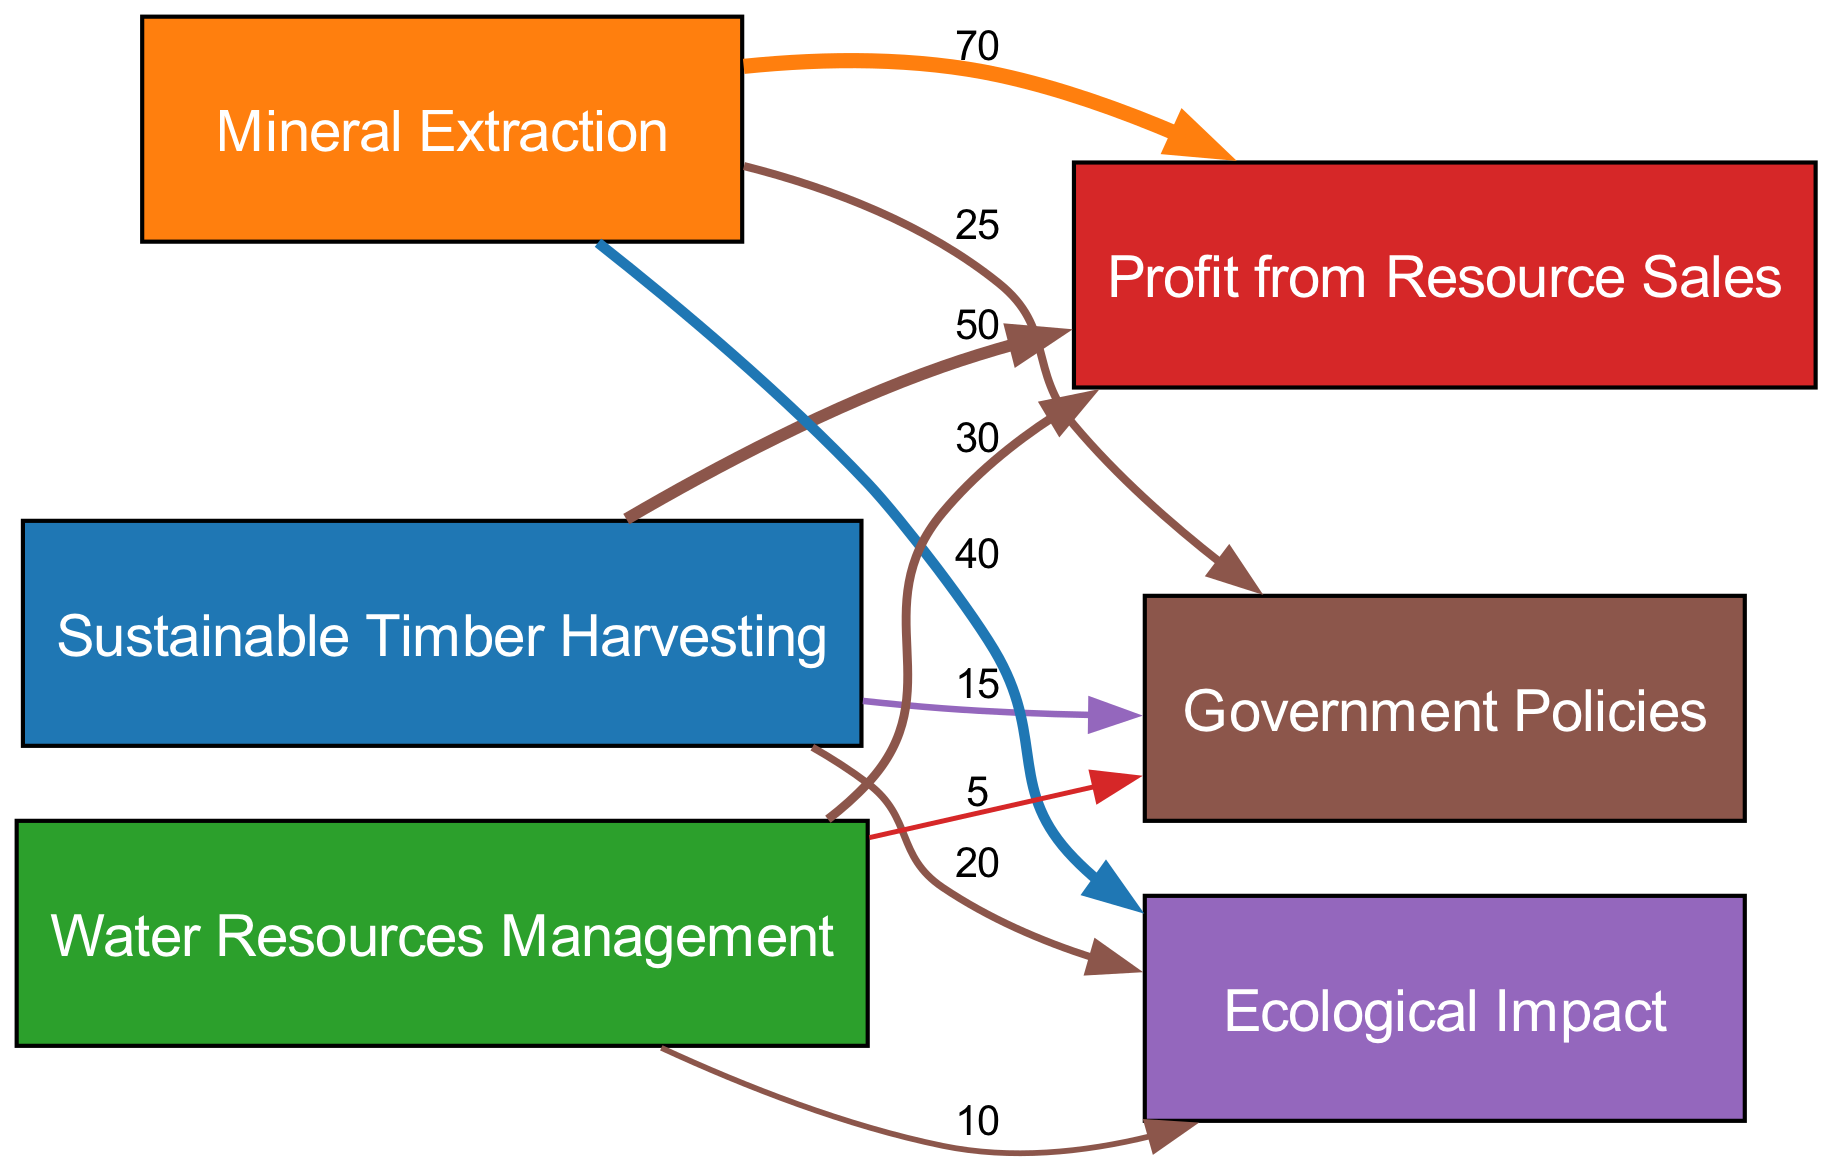What is the total economic gain from mining? The link from Mining to Economic Gain shows a value of 70, which directly represents the economic gain attributed to mining activities.
Answer: 70 What percentage of the economic gain comes from forestry? The economic gain from Forestry is 50. The total economic gain is 70 (mining) + 50 (forestry) + 30 (water rights) = 150. The percentage from forestry is (50/150) * 100 = 33.33%.
Answer: 33.33% How many nodes are there in the diagram? There are a total of six nodes: Forestry, Mining, Water Rights, Economic Gain, Environment, and Regulations.
Answer: 6 What is the total environmental impact from resource extraction? The environmental impacts are: 20 (forestry) + 40 (mining) + 10 (water rights) = 70. This sum represents the total negative impact on the environment due to resource extraction.
Answer: 70 Which resource has the highest environmental impact? Mining has the highest environmental impact with a value of 40 as shown by the link from Mining to the Environment.
Answer: Mining What is the total value flowing into regulations from all resources? The values flowing into Regulations are: 25 (mining) + 15 (forestry) + 5 (water rights) = 45. This represents the total influence of different resources on regulatory measures.
Answer: 45 What is the flow of environmental impact from water rights? The flow from Water Rights to Environment is valued at 10, indicating the ecological impact resulting from water resource management activities.
Answer: 10 Which resource contributes the least to economic gain? Water Rights contributes the least to economic gain with a value of 30 as shown in the flow from Water Rights to Economic Gain.
Answer: Water Rights What fraction of the total regulations flow comes from forestry? The flow into Regulations from Forestry is 15. The total flow into Regulations is 45 (sum of 25 + 15 + 5). The fraction from Forestry is 15/45 = 1/3 or approximately 0.33.
Answer: 1/3 